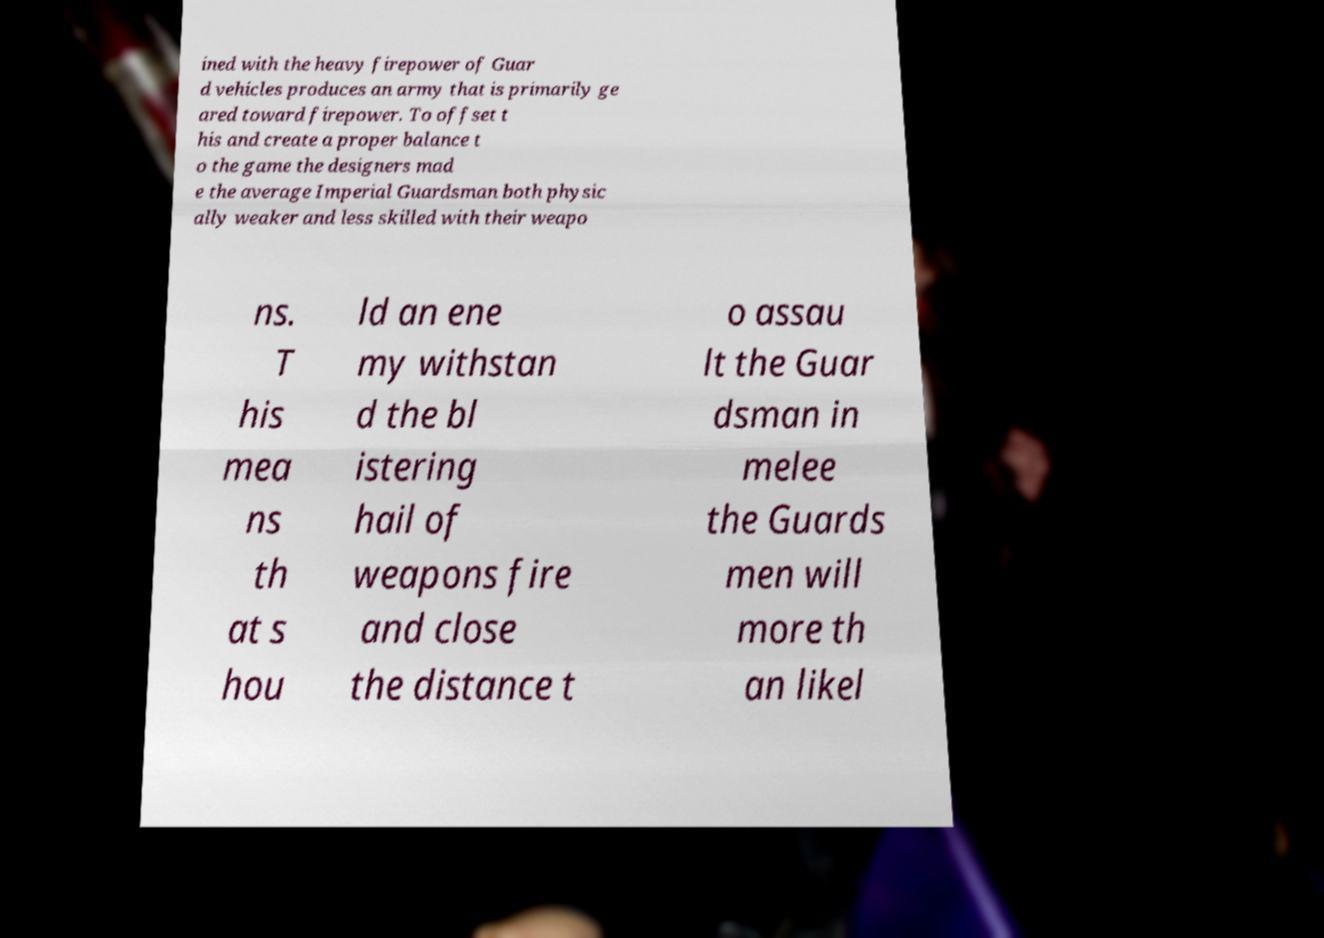Can you accurately transcribe the text from the provided image for me? ined with the heavy firepower of Guar d vehicles produces an army that is primarily ge ared toward firepower. To offset t his and create a proper balance t o the game the designers mad e the average Imperial Guardsman both physic ally weaker and less skilled with their weapo ns. T his mea ns th at s hou ld an ene my withstan d the bl istering hail of weapons fire and close the distance t o assau lt the Guar dsman in melee the Guards men will more th an likel 